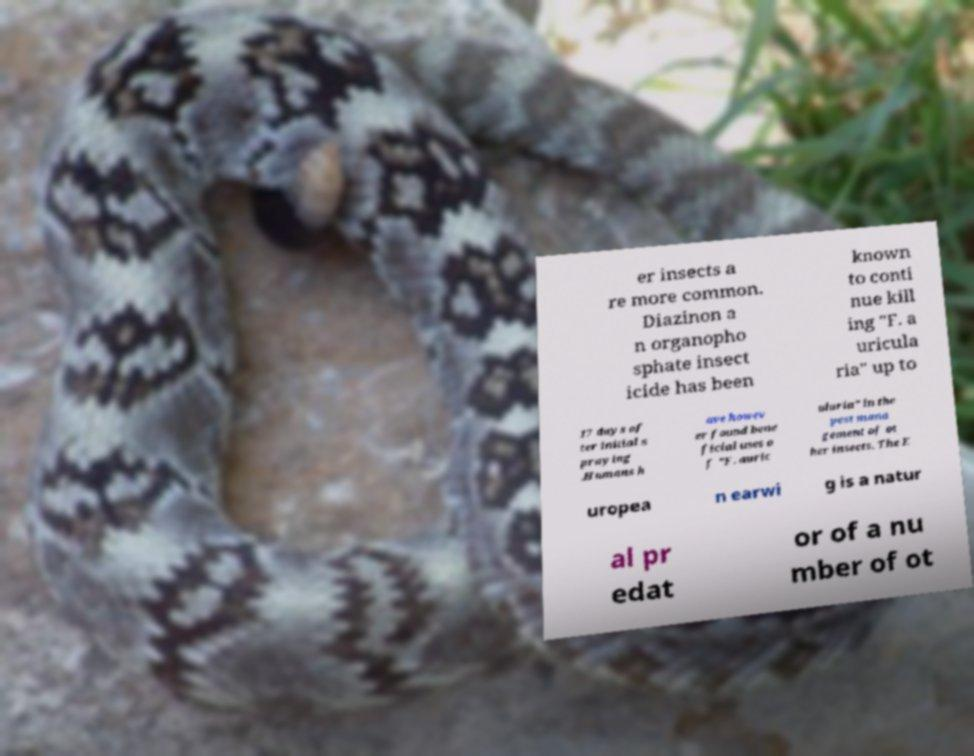Could you assist in decoding the text presented in this image and type it out clearly? er insects a re more common. Diazinon a n organopho sphate insect icide has been known to conti nue kill ing "F. a uricula ria" up to 17 days af ter initial s praying .Humans h ave howev er found bene ficial uses o f "F. auric ularia" in the pest mana gement of ot her insects. The E uropea n earwi g is a natur al pr edat or of a nu mber of ot 